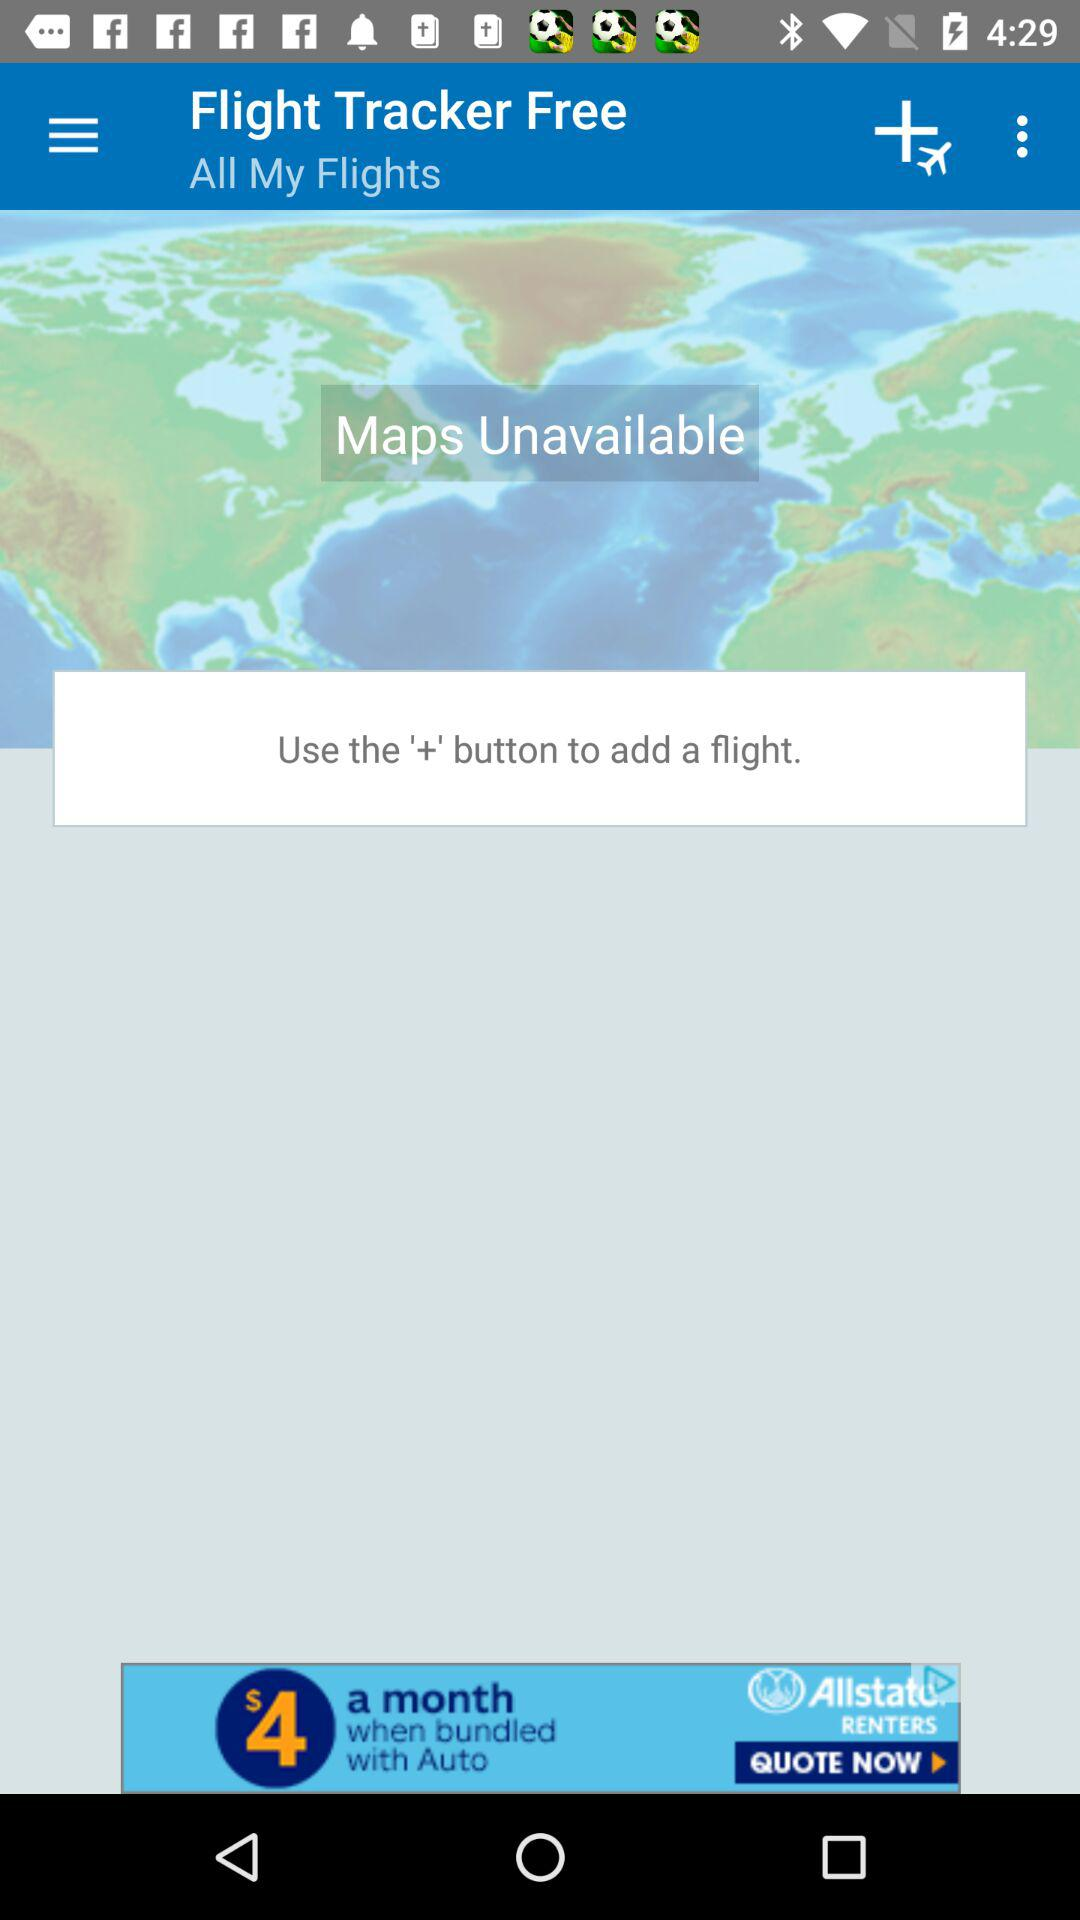What is the name of the application? The name of the application is "Flight Tracker Free". 